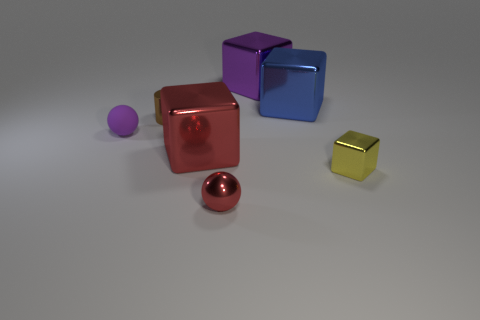What could be the purpose of this arrangement of objects? This arrangement of objects could be for illustrative or educational purposes, showcasing different geometric shapes and colors, possibly for an art project, a graphics rendering demonstration, or a study on light and reflections in photography. 